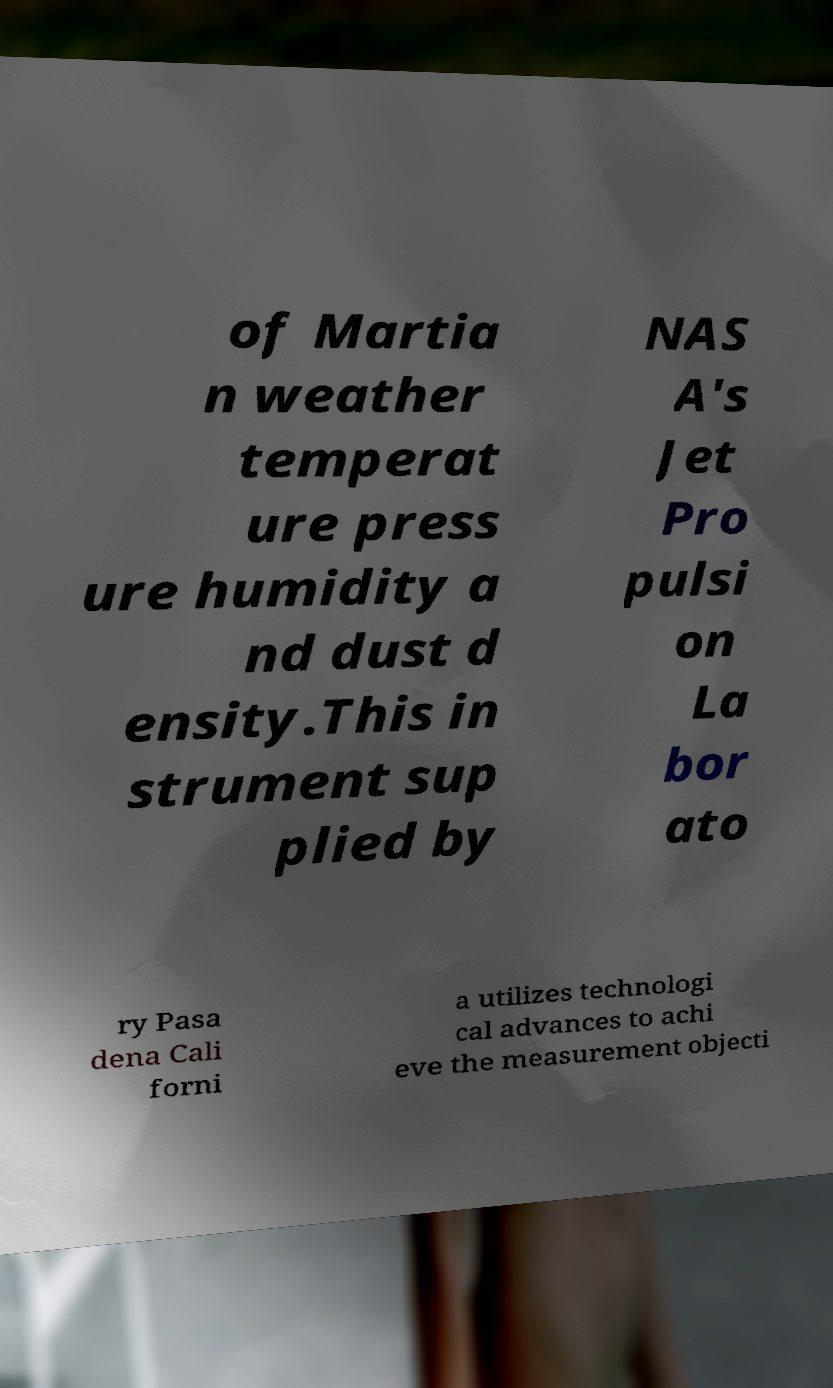Please read and relay the text visible in this image. What does it say? of Martia n weather temperat ure press ure humidity a nd dust d ensity.This in strument sup plied by NAS A's Jet Pro pulsi on La bor ato ry Pasa dena Cali forni a utilizes technologi cal advances to achi eve the measurement objecti 